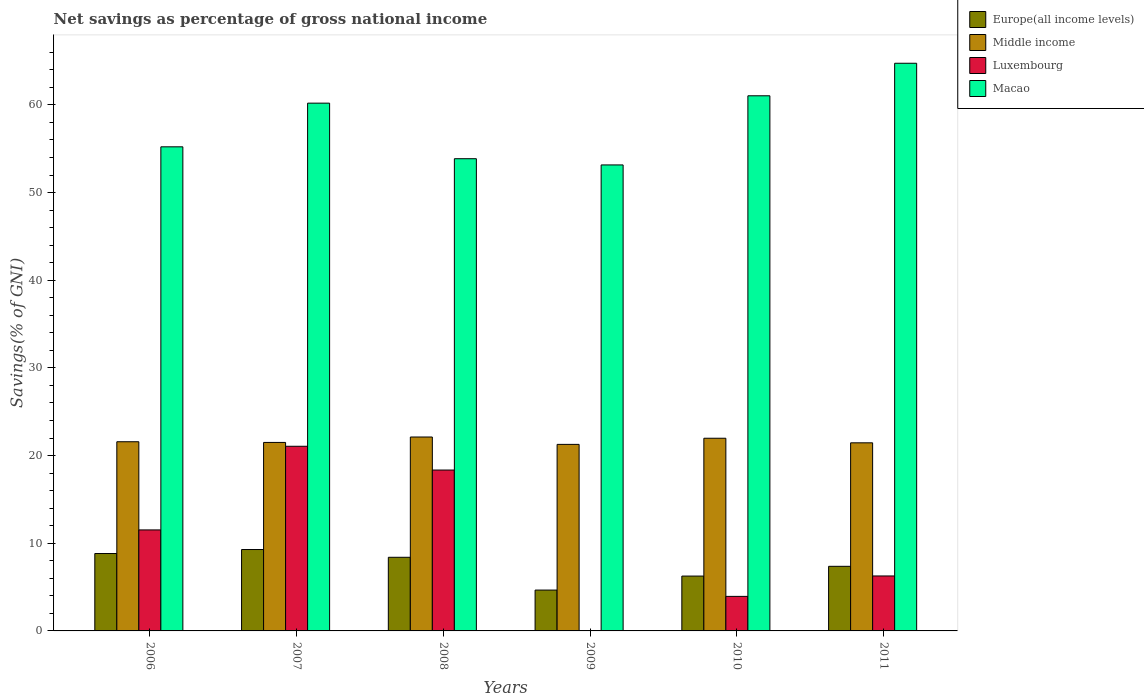Are the number of bars on each tick of the X-axis equal?
Provide a succinct answer. No. How many bars are there on the 5th tick from the right?
Offer a very short reply. 4. In how many cases, is the number of bars for a given year not equal to the number of legend labels?
Your answer should be very brief. 1. What is the total savings in Luxembourg in 2007?
Ensure brevity in your answer.  21.06. Across all years, what is the maximum total savings in Luxembourg?
Offer a terse response. 21.06. Across all years, what is the minimum total savings in Macao?
Keep it short and to the point. 53.16. What is the total total savings in Middle income in the graph?
Keep it short and to the point. 129.92. What is the difference between the total savings in Europe(all income levels) in 2006 and that in 2009?
Your answer should be compact. 4.17. What is the difference between the total savings in Middle income in 2011 and the total savings in Europe(all income levels) in 2010?
Your answer should be very brief. 15.2. What is the average total savings in Europe(all income levels) per year?
Your response must be concise. 7.47. In the year 2010, what is the difference between the total savings in Macao and total savings in Luxembourg?
Keep it short and to the point. 57.1. In how many years, is the total savings in Middle income greater than 64 %?
Ensure brevity in your answer.  0. What is the ratio of the total savings in Europe(all income levels) in 2008 to that in 2011?
Offer a terse response. 1.14. Is the difference between the total savings in Macao in 2007 and 2011 greater than the difference between the total savings in Luxembourg in 2007 and 2011?
Provide a succinct answer. No. What is the difference between the highest and the second highest total savings in Luxembourg?
Offer a terse response. 2.71. What is the difference between the highest and the lowest total savings in Europe(all income levels)?
Your answer should be very brief. 4.63. In how many years, is the total savings in Middle income greater than the average total savings in Middle income taken over all years?
Your answer should be very brief. 2. Is the sum of the total savings in Macao in 2006 and 2009 greater than the maximum total savings in Luxembourg across all years?
Ensure brevity in your answer.  Yes. How many bars are there?
Your answer should be very brief. 23. Are all the bars in the graph horizontal?
Offer a terse response. No. How many years are there in the graph?
Offer a terse response. 6. Are the values on the major ticks of Y-axis written in scientific E-notation?
Your answer should be very brief. No. Does the graph contain grids?
Provide a short and direct response. No. Where does the legend appear in the graph?
Offer a very short reply. Top right. What is the title of the graph?
Keep it short and to the point. Net savings as percentage of gross national income. What is the label or title of the Y-axis?
Your response must be concise. Savings(% of GNI). What is the Savings(% of GNI) of Europe(all income levels) in 2006?
Provide a succinct answer. 8.83. What is the Savings(% of GNI) of Middle income in 2006?
Your response must be concise. 21.58. What is the Savings(% of GNI) of Luxembourg in 2006?
Offer a terse response. 11.52. What is the Savings(% of GNI) of Macao in 2006?
Make the answer very short. 55.22. What is the Savings(% of GNI) of Europe(all income levels) in 2007?
Provide a succinct answer. 9.29. What is the Savings(% of GNI) in Middle income in 2007?
Offer a terse response. 21.5. What is the Savings(% of GNI) of Luxembourg in 2007?
Make the answer very short. 21.06. What is the Savings(% of GNI) in Macao in 2007?
Your response must be concise. 60.2. What is the Savings(% of GNI) in Europe(all income levels) in 2008?
Offer a terse response. 8.4. What is the Savings(% of GNI) in Middle income in 2008?
Keep it short and to the point. 22.12. What is the Savings(% of GNI) in Luxembourg in 2008?
Offer a terse response. 18.35. What is the Savings(% of GNI) of Macao in 2008?
Keep it short and to the point. 53.87. What is the Savings(% of GNI) in Europe(all income levels) in 2009?
Provide a short and direct response. 4.66. What is the Savings(% of GNI) in Middle income in 2009?
Your response must be concise. 21.28. What is the Savings(% of GNI) of Macao in 2009?
Provide a short and direct response. 53.16. What is the Savings(% of GNI) in Europe(all income levels) in 2010?
Make the answer very short. 6.26. What is the Savings(% of GNI) of Middle income in 2010?
Keep it short and to the point. 21.98. What is the Savings(% of GNI) of Luxembourg in 2010?
Your response must be concise. 3.94. What is the Savings(% of GNI) in Macao in 2010?
Your answer should be compact. 61.04. What is the Savings(% of GNI) of Europe(all income levels) in 2011?
Provide a succinct answer. 7.37. What is the Savings(% of GNI) of Middle income in 2011?
Provide a short and direct response. 21.46. What is the Savings(% of GNI) of Luxembourg in 2011?
Give a very brief answer. 6.27. What is the Savings(% of GNI) in Macao in 2011?
Provide a succinct answer. 64.75. Across all years, what is the maximum Savings(% of GNI) of Europe(all income levels)?
Your answer should be compact. 9.29. Across all years, what is the maximum Savings(% of GNI) in Middle income?
Your answer should be very brief. 22.12. Across all years, what is the maximum Savings(% of GNI) in Luxembourg?
Provide a succinct answer. 21.06. Across all years, what is the maximum Savings(% of GNI) of Macao?
Your response must be concise. 64.75. Across all years, what is the minimum Savings(% of GNI) of Europe(all income levels)?
Provide a short and direct response. 4.66. Across all years, what is the minimum Savings(% of GNI) of Middle income?
Make the answer very short. 21.28. Across all years, what is the minimum Savings(% of GNI) in Luxembourg?
Your answer should be compact. 0. Across all years, what is the minimum Savings(% of GNI) of Macao?
Offer a terse response. 53.16. What is the total Savings(% of GNI) of Europe(all income levels) in the graph?
Offer a terse response. 44.8. What is the total Savings(% of GNI) in Middle income in the graph?
Make the answer very short. 129.92. What is the total Savings(% of GNI) of Luxembourg in the graph?
Offer a very short reply. 61.14. What is the total Savings(% of GNI) in Macao in the graph?
Your answer should be very brief. 348.25. What is the difference between the Savings(% of GNI) of Europe(all income levels) in 2006 and that in 2007?
Offer a very short reply. -0.46. What is the difference between the Savings(% of GNI) of Middle income in 2006 and that in 2007?
Your answer should be very brief. 0.08. What is the difference between the Savings(% of GNI) of Luxembourg in 2006 and that in 2007?
Give a very brief answer. -9.54. What is the difference between the Savings(% of GNI) of Macao in 2006 and that in 2007?
Make the answer very short. -4.98. What is the difference between the Savings(% of GNI) in Europe(all income levels) in 2006 and that in 2008?
Offer a terse response. 0.43. What is the difference between the Savings(% of GNI) in Middle income in 2006 and that in 2008?
Your answer should be compact. -0.54. What is the difference between the Savings(% of GNI) in Luxembourg in 2006 and that in 2008?
Offer a terse response. -6.83. What is the difference between the Savings(% of GNI) of Macao in 2006 and that in 2008?
Provide a succinct answer. 1.36. What is the difference between the Savings(% of GNI) of Europe(all income levels) in 2006 and that in 2009?
Your response must be concise. 4.17. What is the difference between the Savings(% of GNI) in Middle income in 2006 and that in 2009?
Offer a very short reply. 0.3. What is the difference between the Savings(% of GNI) of Macao in 2006 and that in 2009?
Your answer should be compact. 2.07. What is the difference between the Savings(% of GNI) in Europe(all income levels) in 2006 and that in 2010?
Give a very brief answer. 2.57. What is the difference between the Savings(% of GNI) of Middle income in 2006 and that in 2010?
Offer a terse response. -0.4. What is the difference between the Savings(% of GNI) of Luxembourg in 2006 and that in 2010?
Your response must be concise. 7.58. What is the difference between the Savings(% of GNI) in Macao in 2006 and that in 2010?
Provide a short and direct response. -5.82. What is the difference between the Savings(% of GNI) in Europe(all income levels) in 2006 and that in 2011?
Offer a very short reply. 1.46. What is the difference between the Savings(% of GNI) in Middle income in 2006 and that in 2011?
Your answer should be very brief. 0.12. What is the difference between the Savings(% of GNI) in Luxembourg in 2006 and that in 2011?
Give a very brief answer. 5.25. What is the difference between the Savings(% of GNI) of Macao in 2006 and that in 2011?
Offer a terse response. -9.53. What is the difference between the Savings(% of GNI) in Europe(all income levels) in 2007 and that in 2008?
Make the answer very short. 0.89. What is the difference between the Savings(% of GNI) in Middle income in 2007 and that in 2008?
Your response must be concise. -0.62. What is the difference between the Savings(% of GNI) in Luxembourg in 2007 and that in 2008?
Your answer should be very brief. 2.71. What is the difference between the Savings(% of GNI) of Macao in 2007 and that in 2008?
Offer a terse response. 6.34. What is the difference between the Savings(% of GNI) of Europe(all income levels) in 2007 and that in 2009?
Offer a terse response. 4.63. What is the difference between the Savings(% of GNI) of Middle income in 2007 and that in 2009?
Ensure brevity in your answer.  0.22. What is the difference between the Savings(% of GNI) in Macao in 2007 and that in 2009?
Offer a terse response. 7.05. What is the difference between the Savings(% of GNI) of Europe(all income levels) in 2007 and that in 2010?
Your response must be concise. 3.03. What is the difference between the Savings(% of GNI) of Middle income in 2007 and that in 2010?
Your answer should be very brief. -0.48. What is the difference between the Savings(% of GNI) of Luxembourg in 2007 and that in 2010?
Your answer should be compact. 17.12. What is the difference between the Savings(% of GNI) in Macao in 2007 and that in 2010?
Offer a terse response. -0.84. What is the difference between the Savings(% of GNI) of Europe(all income levels) in 2007 and that in 2011?
Provide a short and direct response. 1.92. What is the difference between the Savings(% of GNI) in Middle income in 2007 and that in 2011?
Make the answer very short. 0.04. What is the difference between the Savings(% of GNI) in Luxembourg in 2007 and that in 2011?
Provide a succinct answer. 14.79. What is the difference between the Savings(% of GNI) in Macao in 2007 and that in 2011?
Give a very brief answer. -4.55. What is the difference between the Savings(% of GNI) in Europe(all income levels) in 2008 and that in 2009?
Offer a terse response. 3.74. What is the difference between the Savings(% of GNI) of Middle income in 2008 and that in 2009?
Make the answer very short. 0.84. What is the difference between the Savings(% of GNI) of Macao in 2008 and that in 2009?
Keep it short and to the point. 0.71. What is the difference between the Savings(% of GNI) of Europe(all income levels) in 2008 and that in 2010?
Give a very brief answer. 2.14. What is the difference between the Savings(% of GNI) in Middle income in 2008 and that in 2010?
Your answer should be compact. 0.14. What is the difference between the Savings(% of GNI) of Luxembourg in 2008 and that in 2010?
Ensure brevity in your answer.  14.41. What is the difference between the Savings(% of GNI) of Macao in 2008 and that in 2010?
Your response must be concise. -7.18. What is the difference between the Savings(% of GNI) in Europe(all income levels) in 2008 and that in 2011?
Provide a succinct answer. 1.03. What is the difference between the Savings(% of GNI) in Middle income in 2008 and that in 2011?
Your answer should be very brief. 0.66. What is the difference between the Savings(% of GNI) in Luxembourg in 2008 and that in 2011?
Ensure brevity in your answer.  12.08. What is the difference between the Savings(% of GNI) of Macao in 2008 and that in 2011?
Offer a terse response. -10.89. What is the difference between the Savings(% of GNI) of Europe(all income levels) in 2009 and that in 2010?
Your answer should be very brief. -1.6. What is the difference between the Savings(% of GNI) in Middle income in 2009 and that in 2010?
Make the answer very short. -0.7. What is the difference between the Savings(% of GNI) in Macao in 2009 and that in 2010?
Give a very brief answer. -7.89. What is the difference between the Savings(% of GNI) of Europe(all income levels) in 2009 and that in 2011?
Offer a very short reply. -2.71. What is the difference between the Savings(% of GNI) of Middle income in 2009 and that in 2011?
Your answer should be compact. -0.18. What is the difference between the Savings(% of GNI) in Macao in 2009 and that in 2011?
Offer a very short reply. -11.6. What is the difference between the Savings(% of GNI) in Europe(all income levels) in 2010 and that in 2011?
Ensure brevity in your answer.  -1.11. What is the difference between the Savings(% of GNI) in Middle income in 2010 and that in 2011?
Offer a terse response. 0.52. What is the difference between the Savings(% of GNI) of Luxembourg in 2010 and that in 2011?
Your response must be concise. -2.33. What is the difference between the Savings(% of GNI) in Macao in 2010 and that in 2011?
Make the answer very short. -3.71. What is the difference between the Savings(% of GNI) in Europe(all income levels) in 2006 and the Savings(% of GNI) in Middle income in 2007?
Keep it short and to the point. -12.67. What is the difference between the Savings(% of GNI) of Europe(all income levels) in 2006 and the Savings(% of GNI) of Luxembourg in 2007?
Keep it short and to the point. -12.23. What is the difference between the Savings(% of GNI) of Europe(all income levels) in 2006 and the Savings(% of GNI) of Macao in 2007?
Ensure brevity in your answer.  -51.38. What is the difference between the Savings(% of GNI) of Middle income in 2006 and the Savings(% of GNI) of Luxembourg in 2007?
Give a very brief answer. 0.52. What is the difference between the Savings(% of GNI) of Middle income in 2006 and the Savings(% of GNI) of Macao in 2007?
Make the answer very short. -38.62. What is the difference between the Savings(% of GNI) in Luxembourg in 2006 and the Savings(% of GNI) in Macao in 2007?
Keep it short and to the point. -48.68. What is the difference between the Savings(% of GNI) in Europe(all income levels) in 2006 and the Savings(% of GNI) in Middle income in 2008?
Provide a short and direct response. -13.29. What is the difference between the Savings(% of GNI) of Europe(all income levels) in 2006 and the Savings(% of GNI) of Luxembourg in 2008?
Provide a succinct answer. -9.52. What is the difference between the Savings(% of GNI) of Europe(all income levels) in 2006 and the Savings(% of GNI) of Macao in 2008?
Offer a very short reply. -45.04. What is the difference between the Savings(% of GNI) in Middle income in 2006 and the Savings(% of GNI) in Luxembourg in 2008?
Your response must be concise. 3.23. What is the difference between the Savings(% of GNI) of Middle income in 2006 and the Savings(% of GNI) of Macao in 2008?
Keep it short and to the point. -32.29. What is the difference between the Savings(% of GNI) of Luxembourg in 2006 and the Savings(% of GNI) of Macao in 2008?
Your answer should be compact. -42.34. What is the difference between the Savings(% of GNI) in Europe(all income levels) in 2006 and the Savings(% of GNI) in Middle income in 2009?
Ensure brevity in your answer.  -12.45. What is the difference between the Savings(% of GNI) in Europe(all income levels) in 2006 and the Savings(% of GNI) in Macao in 2009?
Offer a very short reply. -44.33. What is the difference between the Savings(% of GNI) of Middle income in 2006 and the Savings(% of GNI) of Macao in 2009?
Make the answer very short. -31.58. What is the difference between the Savings(% of GNI) of Luxembourg in 2006 and the Savings(% of GNI) of Macao in 2009?
Offer a terse response. -41.64. What is the difference between the Savings(% of GNI) of Europe(all income levels) in 2006 and the Savings(% of GNI) of Middle income in 2010?
Offer a terse response. -13.15. What is the difference between the Savings(% of GNI) in Europe(all income levels) in 2006 and the Savings(% of GNI) in Luxembourg in 2010?
Give a very brief answer. 4.89. What is the difference between the Savings(% of GNI) of Europe(all income levels) in 2006 and the Savings(% of GNI) of Macao in 2010?
Offer a terse response. -52.21. What is the difference between the Savings(% of GNI) in Middle income in 2006 and the Savings(% of GNI) in Luxembourg in 2010?
Your answer should be very brief. 17.64. What is the difference between the Savings(% of GNI) in Middle income in 2006 and the Savings(% of GNI) in Macao in 2010?
Make the answer very short. -39.46. What is the difference between the Savings(% of GNI) of Luxembourg in 2006 and the Savings(% of GNI) of Macao in 2010?
Give a very brief answer. -49.52. What is the difference between the Savings(% of GNI) of Europe(all income levels) in 2006 and the Savings(% of GNI) of Middle income in 2011?
Your answer should be very brief. -12.63. What is the difference between the Savings(% of GNI) in Europe(all income levels) in 2006 and the Savings(% of GNI) in Luxembourg in 2011?
Provide a succinct answer. 2.56. What is the difference between the Savings(% of GNI) in Europe(all income levels) in 2006 and the Savings(% of GNI) in Macao in 2011?
Your answer should be compact. -55.93. What is the difference between the Savings(% of GNI) in Middle income in 2006 and the Savings(% of GNI) in Luxembourg in 2011?
Make the answer very short. 15.31. What is the difference between the Savings(% of GNI) in Middle income in 2006 and the Savings(% of GNI) in Macao in 2011?
Make the answer very short. -43.17. What is the difference between the Savings(% of GNI) in Luxembourg in 2006 and the Savings(% of GNI) in Macao in 2011?
Your response must be concise. -53.23. What is the difference between the Savings(% of GNI) in Europe(all income levels) in 2007 and the Savings(% of GNI) in Middle income in 2008?
Provide a short and direct response. -12.84. What is the difference between the Savings(% of GNI) in Europe(all income levels) in 2007 and the Savings(% of GNI) in Luxembourg in 2008?
Keep it short and to the point. -9.07. What is the difference between the Savings(% of GNI) in Europe(all income levels) in 2007 and the Savings(% of GNI) in Macao in 2008?
Your answer should be very brief. -44.58. What is the difference between the Savings(% of GNI) of Middle income in 2007 and the Savings(% of GNI) of Luxembourg in 2008?
Offer a very short reply. 3.15. What is the difference between the Savings(% of GNI) in Middle income in 2007 and the Savings(% of GNI) in Macao in 2008?
Offer a very short reply. -32.36. What is the difference between the Savings(% of GNI) in Luxembourg in 2007 and the Savings(% of GNI) in Macao in 2008?
Ensure brevity in your answer.  -32.8. What is the difference between the Savings(% of GNI) of Europe(all income levels) in 2007 and the Savings(% of GNI) of Middle income in 2009?
Provide a short and direct response. -11.99. What is the difference between the Savings(% of GNI) in Europe(all income levels) in 2007 and the Savings(% of GNI) in Macao in 2009?
Offer a very short reply. -43.87. What is the difference between the Savings(% of GNI) of Middle income in 2007 and the Savings(% of GNI) of Macao in 2009?
Make the answer very short. -31.65. What is the difference between the Savings(% of GNI) of Luxembourg in 2007 and the Savings(% of GNI) of Macao in 2009?
Your answer should be compact. -32.09. What is the difference between the Savings(% of GNI) in Europe(all income levels) in 2007 and the Savings(% of GNI) in Middle income in 2010?
Your answer should be compact. -12.69. What is the difference between the Savings(% of GNI) of Europe(all income levels) in 2007 and the Savings(% of GNI) of Luxembourg in 2010?
Your answer should be very brief. 5.35. What is the difference between the Savings(% of GNI) in Europe(all income levels) in 2007 and the Savings(% of GNI) in Macao in 2010?
Offer a very short reply. -51.76. What is the difference between the Savings(% of GNI) in Middle income in 2007 and the Savings(% of GNI) in Luxembourg in 2010?
Your response must be concise. 17.56. What is the difference between the Savings(% of GNI) of Middle income in 2007 and the Savings(% of GNI) of Macao in 2010?
Provide a succinct answer. -39.54. What is the difference between the Savings(% of GNI) in Luxembourg in 2007 and the Savings(% of GNI) in Macao in 2010?
Your answer should be compact. -39.98. What is the difference between the Savings(% of GNI) of Europe(all income levels) in 2007 and the Savings(% of GNI) of Middle income in 2011?
Keep it short and to the point. -12.17. What is the difference between the Savings(% of GNI) in Europe(all income levels) in 2007 and the Savings(% of GNI) in Luxembourg in 2011?
Give a very brief answer. 3.02. What is the difference between the Savings(% of GNI) in Europe(all income levels) in 2007 and the Savings(% of GNI) in Macao in 2011?
Give a very brief answer. -55.47. What is the difference between the Savings(% of GNI) of Middle income in 2007 and the Savings(% of GNI) of Luxembourg in 2011?
Provide a short and direct response. 15.23. What is the difference between the Savings(% of GNI) of Middle income in 2007 and the Savings(% of GNI) of Macao in 2011?
Your answer should be compact. -43.25. What is the difference between the Savings(% of GNI) in Luxembourg in 2007 and the Savings(% of GNI) in Macao in 2011?
Provide a short and direct response. -43.69. What is the difference between the Savings(% of GNI) in Europe(all income levels) in 2008 and the Savings(% of GNI) in Middle income in 2009?
Keep it short and to the point. -12.88. What is the difference between the Savings(% of GNI) of Europe(all income levels) in 2008 and the Savings(% of GNI) of Macao in 2009?
Ensure brevity in your answer.  -44.76. What is the difference between the Savings(% of GNI) of Middle income in 2008 and the Savings(% of GNI) of Macao in 2009?
Your answer should be compact. -31.04. What is the difference between the Savings(% of GNI) in Luxembourg in 2008 and the Savings(% of GNI) in Macao in 2009?
Your answer should be compact. -34.81. What is the difference between the Savings(% of GNI) in Europe(all income levels) in 2008 and the Savings(% of GNI) in Middle income in 2010?
Offer a very short reply. -13.58. What is the difference between the Savings(% of GNI) in Europe(all income levels) in 2008 and the Savings(% of GNI) in Luxembourg in 2010?
Provide a succinct answer. 4.46. What is the difference between the Savings(% of GNI) in Europe(all income levels) in 2008 and the Savings(% of GNI) in Macao in 2010?
Keep it short and to the point. -52.64. What is the difference between the Savings(% of GNI) in Middle income in 2008 and the Savings(% of GNI) in Luxembourg in 2010?
Provide a succinct answer. 18.18. What is the difference between the Savings(% of GNI) of Middle income in 2008 and the Savings(% of GNI) of Macao in 2010?
Give a very brief answer. -38.92. What is the difference between the Savings(% of GNI) of Luxembourg in 2008 and the Savings(% of GNI) of Macao in 2010?
Offer a very short reply. -42.69. What is the difference between the Savings(% of GNI) of Europe(all income levels) in 2008 and the Savings(% of GNI) of Middle income in 2011?
Keep it short and to the point. -13.06. What is the difference between the Savings(% of GNI) in Europe(all income levels) in 2008 and the Savings(% of GNI) in Luxembourg in 2011?
Ensure brevity in your answer.  2.13. What is the difference between the Savings(% of GNI) of Europe(all income levels) in 2008 and the Savings(% of GNI) of Macao in 2011?
Your answer should be very brief. -56.35. What is the difference between the Savings(% of GNI) in Middle income in 2008 and the Savings(% of GNI) in Luxembourg in 2011?
Your response must be concise. 15.85. What is the difference between the Savings(% of GNI) in Middle income in 2008 and the Savings(% of GNI) in Macao in 2011?
Your answer should be very brief. -42.63. What is the difference between the Savings(% of GNI) of Luxembourg in 2008 and the Savings(% of GNI) of Macao in 2011?
Your answer should be compact. -46.4. What is the difference between the Savings(% of GNI) in Europe(all income levels) in 2009 and the Savings(% of GNI) in Middle income in 2010?
Give a very brief answer. -17.32. What is the difference between the Savings(% of GNI) of Europe(all income levels) in 2009 and the Savings(% of GNI) of Luxembourg in 2010?
Keep it short and to the point. 0.72. What is the difference between the Savings(% of GNI) in Europe(all income levels) in 2009 and the Savings(% of GNI) in Macao in 2010?
Offer a terse response. -56.38. What is the difference between the Savings(% of GNI) of Middle income in 2009 and the Savings(% of GNI) of Luxembourg in 2010?
Provide a succinct answer. 17.34. What is the difference between the Savings(% of GNI) of Middle income in 2009 and the Savings(% of GNI) of Macao in 2010?
Your answer should be compact. -39.76. What is the difference between the Savings(% of GNI) in Europe(all income levels) in 2009 and the Savings(% of GNI) in Middle income in 2011?
Your response must be concise. -16.8. What is the difference between the Savings(% of GNI) in Europe(all income levels) in 2009 and the Savings(% of GNI) in Luxembourg in 2011?
Keep it short and to the point. -1.61. What is the difference between the Savings(% of GNI) in Europe(all income levels) in 2009 and the Savings(% of GNI) in Macao in 2011?
Offer a very short reply. -60.09. What is the difference between the Savings(% of GNI) of Middle income in 2009 and the Savings(% of GNI) of Luxembourg in 2011?
Your answer should be very brief. 15.01. What is the difference between the Savings(% of GNI) in Middle income in 2009 and the Savings(% of GNI) in Macao in 2011?
Your answer should be compact. -43.47. What is the difference between the Savings(% of GNI) in Europe(all income levels) in 2010 and the Savings(% of GNI) in Middle income in 2011?
Keep it short and to the point. -15.2. What is the difference between the Savings(% of GNI) of Europe(all income levels) in 2010 and the Savings(% of GNI) of Luxembourg in 2011?
Your answer should be compact. -0.01. What is the difference between the Savings(% of GNI) of Europe(all income levels) in 2010 and the Savings(% of GNI) of Macao in 2011?
Your answer should be compact. -58.5. What is the difference between the Savings(% of GNI) in Middle income in 2010 and the Savings(% of GNI) in Luxembourg in 2011?
Provide a succinct answer. 15.71. What is the difference between the Savings(% of GNI) in Middle income in 2010 and the Savings(% of GNI) in Macao in 2011?
Make the answer very short. -42.78. What is the difference between the Savings(% of GNI) in Luxembourg in 2010 and the Savings(% of GNI) in Macao in 2011?
Your response must be concise. -60.81. What is the average Savings(% of GNI) in Europe(all income levels) per year?
Offer a terse response. 7.47. What is the average Savings(% of GNI) of Middle income per year?
Offer a very short reply. 21.65. What is the average Savings(% of GNI) in Luxembourg per year?
Give a very brief answer. 10.19. What is the average Savings(% of GNI) of Macao per year?
Ensure brevity in your answer.  58.04. In the year 2006, what is the difference between the Savings(% of GNI) of Europe(all income levels) and Savings(% of GNI) of Middle income?
Offer a very short reply. -12.75. In the year 2006, what is the difference between the Savings(% of GNI) of Europe(all income levels) and Savings(% of GNI) of Luxembourg?
Your answer should be very brief. -2.69. In the year 2006, what is the difference between the Savings(% of GNI) in Europe(all income levels) and Savings(% of GNI) in Macao?
Your answer should be compact. -46.39. In the year 2006, what is the difference between the Savings(% of GNI) of Middle income and Savings(% of GNI) of Luxembourg?
Keep it short and to the point. 10.06. In the year 2006, what is the difference between the Savings(% of GNI) in Middle income and Savings(% of GNI) in Macao?
Provide a short and direct response. -33.64. In the year 2006, what is the difference between the Savings(% of GNI) in Luxembourg and Savings(% of GNI) in Macao?
Offer a terse response. -43.7. In the year 2007, what is the difference between the Savings(% of GNI) in Europe(all income levels) and Savings(% of GNI) in Middle income?
Your answer should be compact. -12.22. In the year 2007, what is the difference between the Savings(% of GNI) in Europe(all income levels) and Savings(% of GNI) in Luxembourg?
Provide a short and direct response. -11.78. In the year 2007, what is the difference between the Savings(% of GNI) of Europe(all income levels) and Savings(% of GNI) of Macao?
Your answer should be compact. -50.92. In the year 2007, what is the difference between the Savings(% of GNI) in Middle income and Savings(% of GNI) in Luxembourg?
Your answer should be compact. 0.44. In the year 2007, what is the difference between the Savings(% of GNI) in Middle income and Savings(% of GNI) in Macao?
Make the answer very short. -38.7. In the year 2007, what is the difference between the Savings(% of GNI) in Luxembourg and Savings(% of GNI) in Macao?
Provide a short and direct response. -39.14. In the year 2008, what is the difference between the Savings(% of GNI) of Europe(all income levels) and Savings(% of GNI) of Middle income?
Provide a short and direct response. -13.72. In the year 2008, what is the difference between the Savings(% of GNI) of Europe(all income levels) and Savings(% of GNI) of Luxembourg?
Make the answer very short. -9.95. In the year 2008, what is the difference between the Savings(% of GNI) of Europe(all income levels) and Savings(% of GNI) of Macao?
Give a very brief answer. -45.47. In the year 2008, what is the difference between the Savings(% of GNI) of Middle income and Savings(% of GNI) of Luxembourg?
Provide a short and direct response. 3.77. In the year 2008, what is the difference between the Savings(% of GNI) of Middle income and Savings(% of GNI) of Macao?
Provide a succinct answer. -31.75. In the year 2008, what is the difference between the Savings(% of GNI) in Luxembourg and Savings(% of GNI) in Macao?
Your answer should be compact. -35.51. In the year 2009, what is the difference between the Savings(% of GNI) in Europe(all income levels) and Savings(% of GNI) in Middle income?
Make the answer very short. -16.62. In the year 2009, what is the difference between the Savings(% of GNI) in Europe(all income levels) and Savings(% of GNI) in Macao?
Make the answer very short. -48.5. In the year 2009, what is the difference between the Savings(% of GNI) of Middle income and Savings(% of GNI) of Macao?
Your response must be concise. -31.88. In the year 2010, what is the difference between the Savings(% of GNI) of Europe(all income levels) and Savings(% of GNI) of Middle income?
Offer a terse response. -15.72. In the year 2010, what is the difference between the Savings(% of GNI) in Europe(all income levels) and Savings(% of GNI) in Luxembourg?
Provide a short and direct response. 2.32. In the year 2010, what is the difference between the Savings(% of GNI) of Europe(all income levels) and Savings(% of GNI) of Macao?
Your answer should be compact. -54.79. In the year 2010, what is the difference between the Savings(% of GNI) of Middle income and Savings(% of GNI) of Luxembourg?
Make the answer very short. 18.04. In the year 2010, what is the difference between the Savings(% of GNI) in Middle income and Savings(% of GNI) in Macao?
Your response must be concise. -39.07. In the year 2010, what is the difference between the Savings(% of GNI) of Luxembourg and Savings(% of GNI) of Macao?
Give a very brief answer. -57.1. In the year 2011, what is the difference between the Savings(% of GNI) of Europe(all income levels) and Savings(% of GNI) of Middle income?
Your answer should be compact. -14.09. In the year 2011, what is the difference between the Savings(% of GNI) of Europe(all income levels) and Savings(% of GNI) of Luxembourg?
Give a very brief answer. 1.1. In the year 2011, what is the difference between the Savings(% of GNI) of Europe(all income levels) and Savings(% of GNI) of Macao?
Offer a terse response. -57.39. In the year 2011, what is the difference between the Savings(% of GNI) in Middle income and Savings(% of GNI) in Luxembourg?
Your answer should be very brief. 15.19. In the year 2011, what is the difference between the Savings(% of GNI) of Middle income and Savings(% of GNI) of Macao?
Your response must be concise. -43.3. In the year 2011, what is the difference between the Savings(% of GNI) in Luxembourg and Savings(% of GNI) in Macao?
Provide a succinct answer. -58.48. What is the ratio of the Savings(% of GNI) of Europe(all income levels) in 2006 to that in 2007?
Provide a succinct answer. 0.95. What is the ratio of the Savings(% of GNI) in Luxembourg in 2006 to that in 2007?
Offer a terse response. 0.55. What is the ratio of the Savings(% of GNI) of Macao in 2006 to that in 2007?
Give a very brief answer. 0.92. What is the ratio of the Savings(% of GNI) of Europe(all income levels) in 2006 to that in 2008?
Keep it short and to the point. 1.05. What is the ratio of the Savings(% of GNI) of Middle income in 2006 to that in 2008?
Provide a succinct answer. 0.98. What is the ratio of the Savings(% of GNI) in Luxembourg in 2006 to that in 2008?
Your response must be concise. 0.63. What is the ratio of the Savings(% of GNI) in Macao in 2006 to that in 2008?
Make the answer very short. 1.03. What is the ratio of the Savings(% of GNI) of Europe(all income levels) in 2006 to that in 2009?
Provide a succinct answer. 1.89. What is the ratio of the Savings(% of GNI) of Middle income in 2006 to that in 2009?
Keep it short and to the point. 1.01. What is the ratio of the Savings(% of GNI) in Macao in 2006 to that in 2009?
Offer a terse response. 1.04. What is the ratio of the Savings(% of GNI) in Europe(all income levels) in 2006 to that in 2010?
Keep it short and to the point. 1.41. What is the ratio of the Savings(% of GNI) of Middle income in 2006 to that in 2010?
Give a very brief answer. 0.98. What is the ratio of the Savings(% of GNI) of Luxembourg in 2006 to that in 2010?
Your response must be concise. 2.92. What is the ratio of the Savings(% of GNI) in Macao in 2006 to that in 2010?
Offer a very short reply. 0.9. What is the ratio of the Savings(% of GNI) in Europe(all income levels) in 2006 to that in 2011?
Your answer should be compact. 1.2. What is the ratio of the Savings(% of GNI) in Luxembourg in 2006 to that in 2011?
Offer a very short reply. 1.84. What is the ratio of the Savings(% of GNI) of Macao in 2006 to that in 2011?
Keep it short and to the point. 0.85. What is the ratio of the Savings(% of GNI) of Europe(all income levels) in 2007 to that in 2008?
Make the answer very short. 1.11. What is the ratio of the Savings(% of GNI) in Middle income in 2007 to that in 2008?
Your response must be concise. 0.97. What is the ratio of the Savings(% of GNI) in Luxembourg in 2007 to that in 2008?
Provide a short and direct response. 1.15. What is the ratio of the Savings(% of GNI) of Macao in 2007 to that in 2008?
Keep it short and to the point. 1.12. What is the ratio of the Savings(% of GNI) in Europe(all income levels) in 2007 to that in 2009?
Your answer should be compact. 1.99. What is the ratio of the Savings(% of GNI) of Middle income in 2007 to that in 2009?
Keep it short and to the point. 1.01. What is the ratio of the Savings(% of GNI) in Macao in 2007 to that in 2009?
Provide a short and direct response. 1.13. What is the ratio of the Savings(% of GNI) of Europe(all income levels) in 2007 to that in 2010?
Make the answer very short. 1.48. What is the ratio of the Savings(% of GNI) in Middle income in 2007 to that in 2010?
Give a very brief answer. 0.98. What is the ratio of the Savings(% of GNI) in Luxembourg in 2007 to that in 2010?
Offer a very short reply. 5.35. What is the ratio of the Savings(% of GNI) of Macao in 2007 to that in 2010?
Provide a succinct answer. 0.99. What is the ratio of the Savings(% of GNI) of Europe(all income levels) in 2007 to that in 2011?
Provide a succinct answer. 1.26. What is the ratio of the Savings(% of GNI) of Middle income in 2007 to that in 2011?
Your answer should be very brief. 1. What is the ratio of the Savings(% of GNI) of Luxembourg in 2007 to that in 2011?
Offer a very short reply. 3.36. What is the ratio of the Savings(% of GNI) in Macao in 2007 to that in 2011?
Your answer should be compact. 0.93. What is the ratio of the Savings(% of GNI) of Europe(all income levels) in 2008 to that in 2009?
Offer a terse response. 1.8. What is the ratio of the Savings(% of GNI) of Middle income in 2008 to that in 2009?
Provide a short and direct response. 1.04. What is the ratio of the Savings(% of GNI) of Macao in 2008 to that in 2009?
Your response must be concise. 1.01. What is the ratio of the Savings(% of GNI) in Europe(all income levels) in 2008 to that in 2010?
Offer a terse response. 1.34. What is the ratio of the Savings(% of GNI) in Middle income in 2008 to that in 2010?
Provide a succinct answer. 1.01. What is the ratio of the Savings(% of GNI) of Luxembourg in 2008 to that in 2010?
Make the answer very short. 4.66. What is the ratio of the Savings(% of GNI) in Macao in 2008 to that in 2010?
Your answer should be very brief. 0.88. What is the ratio of the Savings(% of GNI) in Europe(all income levels) in 2008 to that in 2011?
Make the answer very short. 1.14. What is the ratio of the Savings(% of GNI) in Middle income in 2008 to that in 2011?
Offer a terse response. 1.03. What is the ratio of the Savings(% of GNI) in Luxembourg in 2008 to that in 2011?
Provide a succinct answer. 2.93. What is the ratio of the Savings(% of GNI) of Macao in 2008 to that in 2011?
Provide a succinct answer. 0.83. What is the ratio of the Savings(% of GNI) in Europe(all income levels) in 2009 to that in 2010?
Provide a short and direct response. 0.74. What is the ratio of the Savings(% of GNI) of Middle income in 2009 to that in 2010?
Provide a succinct answer. 0.97. What is the ratio of the Savings(% of GNI) in Macao in 2009 to that in 2010?
Provide a succinct answer. 0.87. What is the ratio of the Savings(% of GNI) in Europe(all income levels) in 2009 to that in 2011?
Keep it short and to the point. 0.63. What is the ratio of the Savings(% of GNI) in Macao in 2009 to that in 2011?
Your answer should be compact. 0.82. What is the ratio of the Savings(% of GNI) in Europe(all income levels) in 2010 to that in 2011?
Ensure brevity in your answer.  0.85. What is the ratio of the Savings(% of GNI) of Middle income in 2010 to that in 2011?
Provide a succinct answer. 1.02. What is the ratio of the Savings(% of GNI) in Luxembourg in 2010 to that in 2011?
Your answer should be compact. 0.63. What is the ratio of the Savings(% of GNI) in Macao in 2010 to that in 2011?
Provide a short and direct response. 0.94. What is the difference between the highest and the second highest Savings(% of GNI) in Europe(all income levels)?
Provide a succinct answer. 0.46. What is the difference between the highest and the second highest Savings(% of GNI) in Middle income?
Your response must be concise. 0.14. What is the difference between the highest and the second highest Savings(% of GNI) of Luxembourg?
Keep it short and to the point. 2.71. What is the difference between the highest and the second highest Savings(% of GNI) of Macao?
Offer a very short reply. 3.71. What is the difference between the highest and the lowest Savings(% of GNI) in Europe(all income levels)?
Offer a very short reply. 4.63. What is the difference between the highest and the lowest Savings(% of GNI) in Middle income?
Your answer should be compact. 0.84. What is the difference between the highest and the lowest Savings(% of GNI) in Luxembourg?
Your answer should be very brief. 21.06. What is the difference between the highest and the lowest Savings(% of GNI) in Macao?
Keep it short and to the point. 11.6. 